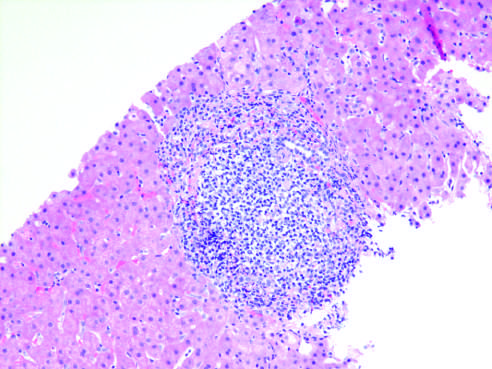does reversibly injured myocardium show characteristic portal tract expansion by a dense lymphoid infiltrate?
Answer the question using a single word or phrase. No 